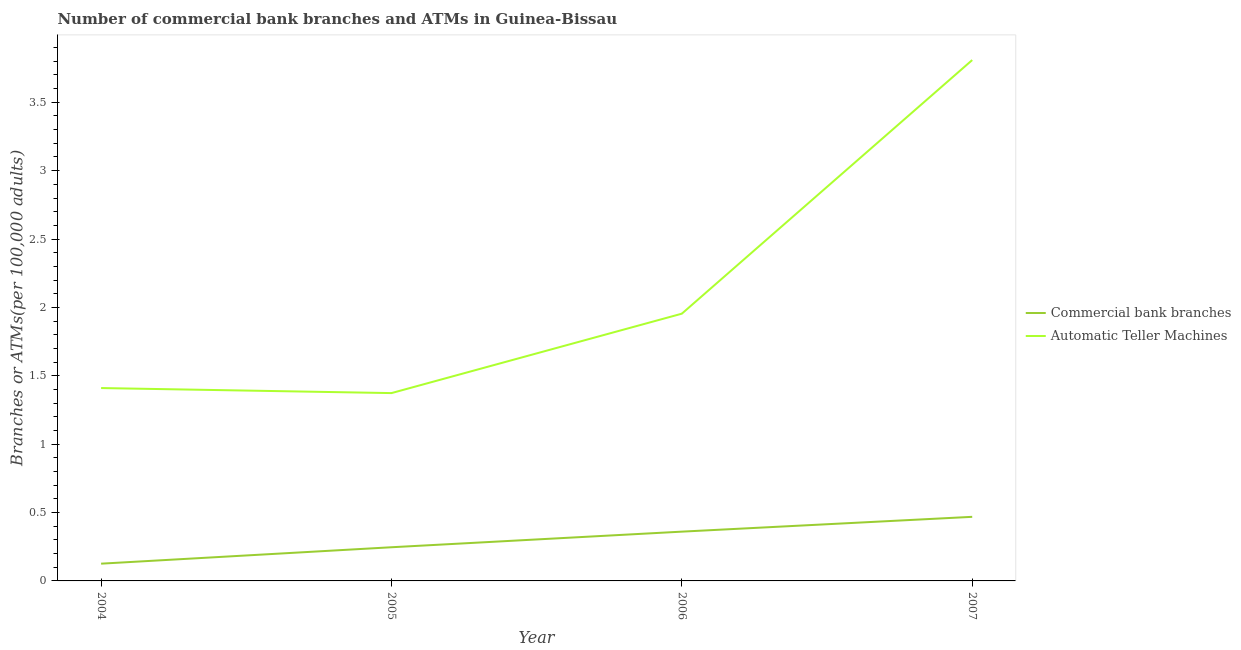How many different coloured lines are there?
Give a very brief answer. 2. Is the number of lines equal to the number of legend labels?
Offer a very short reply. Yes. What is the number of commercal bank branches in 2004?
Keep it short and to the point. 0.13. Across all years, what is the maximum number of atms?
Offer a very short reply. 3.81. Across all years, what is the minimum number of atms?
Offer a terse response. 1.37. In which year was the number of atms minimum?
Provide a succinct answer. 2005. What is the total number of commercal bank branches in the graph?
Your answer should be very brief. 1.2. What is the difference between the number of commercal bank branches in 2004 and that in 2005?
Provide a short and direct response. -0.12. What is the difference between the number of atms in 2005 and the number of commercal bank branches in 2006?
Ensure brevity in your answer.  1.01. What is the average number of atms per year?
Your answer should be compact. 2.14. In the year 2006, what is the difference between the number of atms and number of commercal bank branches?
Keep it short and to the point. 1.59. What is the ratio of the number of atms in 2005 to that in 2007?
Provide a short and direct response. 0.36. Is the number of atms in 2004 less than that in 2007?
Make the answer very short. Yes. Is the difference between the number of atms in 2004 and 2005 greater than the difference between the number of commercal bank branches in 2004 and 2005?
Keep it short and to the point. Yes. What is the difference between the highest and the second highest number of commercal bank branches?
Your answer should be very brief. 0.11. What is the difference between the highest and the lowest number of commercal bank branches?
Offer a very short reply. 0.34. In how many years, is the number of atms greater than the average number of atms taken over all years?
Provide a short and direct response. 1. Is the sum of the number of atms in 2006 and 2007 greater than the maximum number of commercal bank branches across all years?
Offer a very short reply. Yes. Does the number of atms monotonically increase over the years?
Make the answer very short. No. Is the number of atms strictly less than the number of commercal bank branches over the years?
Give a very brief answer. No. How many years are there in the graph?
Offer a terse response. 4. What is the difference between two consecutive major ticks on the Y-axis?
Offer a terse response. 0.5. Does the graph contain grids?
Offer a very short reply. No. How many legend labels are there?
Provide a short and direct response. 2. What is the title of the graph?
Your response must be concise. Number of commercial bank branches and ATMs in Guinea-Bissau. Does "Largest city" appear as one of the legend labels in the graph?
Provide a succinct answer. No. What is the label or title of the Y-axis?
Provide a short and direct response. Branches or ATMs(per 100,0 adults). What is the Branches or ATMs(per 100,000 adults) of Commercial bank branches in 2004?
Keep it short and to the point. 0.13. What is the Branches or ATMs(per 100,000 adults) in Automatic Teller Machines in 2004?
Ensure brevity in your answer.  1.41. What is the Branches or ATMs(per 100,000 adults) in Commercial bank branches in 2005?
Keep it short and to the point. 0.25. What is the Branches or ATMs(per 100,000 adults) of Automatic Teller Machines in 2005?
Offer a very short reply. 1.37. What is the Branches or ATMs(per 100,000 adults) of Commercial bank branches in 2006?
Your answer should be compact. 0.36. What is the Branches or ATMs(per 100,000 adults) of Automatic Teller Machines in 2006?
Your answer should be compact. 1.95. What is the Branches or ATMs(per 100,000 adults) of Commercial bank branches in 2007?
Make the answer very short. 0.47. What is the Branches or ATMs(per 100,000 adults) of Automatic Teller Machines in 2007?
Give a very brief answer. 3.81. Across all years, what is the maximum Branches or ATMs(per 100,000 adults) of Commercial bank branches?
Your answer should be very brief. 0.47. Across all years, what is the maximum Branches or ATMs(per 100,000 adults) of Automatic Teller Machines?
Give a very brief answer. 3.81. Across all years, what is the minimum Branches or ATMs(per 100,000 adults) in Commercial bank branches?
Your answer should be compact. 0.13. Across all years, what is the minimum Branches or ATMs(per 100,000 adults) of Automatic Teller Machines?
Ensure brevity in your answer.  1.37. What is the total Branches or ATMs(per 100,000 adults) in Commercial bank branches in the graph?
Give a very brief answer. 1.2. What is the total Branches or ATMs(per 100,000 adults) in Automatic Teller Machines in the graph?
Ensure brevity in your answer.  8.55. What is the difference between the Branches or ATMs(per 100,000 adults) of Commercial bank branches in 2004 and that in 2005?
Give a very brief answer. -0.12. What is the difference between the Branches or ATMs(per 100,000 adults) in Automatic Teller Machines in 2004 and that in 2005?
Make the answer very short. 0.04. What is the difference between the Branches or ATMs(per 100,000 adults) in Commercial bank branches in 2004 and that in 2006?
Give a very brief answer. -0.23. What is the difference between the Branches or ATMs(per 100,000 adults) in Automatic Teller Machines in 2004 and that in 2006?
Provide a short and direct response. -0.54. What is the difference between the Branches or ATMs(per 100,000 adults) of Commercial bank branches in 2004 and that in 2007?
Provide a short and direct response. -0.34. What is the difference between the Branches or ATMs(per 100,000 adults) of Automatic Teller Machines in 2004 and that in 2007?
Give a very brief answer. -2.4. What is the difference between the Branches or ATMs(per 100,000 adults) of Commercial bank branches in 2005 and that in 2006?
Keep it short and to the point. -0.11. What is the difference between the Branches or ATMs(per 100,000 adults) of Automatic Teller Machines in 2005 and that in 2006?
Your answer should be compact. -0.58. What is the difference between the Branches or ATMs(per 100,000 adults) of Commercial bank branches in 2005 and that in 2007?
Your answer should be compact. -0.22. What is the difference between the Branches or ATMs(per 100,000 adults) of Automatic Teller Machines in 2005 and that in 2007?
Offer a terse response. -2.44. What is the difference between the Branches or ATMs(per 100,000 adults) in Commercial bank branches in 2006 and that in 2007?
Your response must be concise. -0.11. What is the difference between the Branches or ATMs(per 100,000 adults) of Automatic Teller Machines in 2006 and that in 2007?
Your answer should be very brief. -1.85. What is the difference between the Branches or ATMs(per 100,000 adults) of Commercial bank branches in 2004 and the Branches or ATMs(per 100,000 adults) of Automatic Teller Machines in 2005?
Give a very brief answer. -1.25. What is the difference between the Branches or ATMs(per 100,000 adults) of Commercial bank branches in 2004 and the Branches or ATMs(per 100,000 adults) of Automatic Teller Machines in 2006?
Your answer should be compact. -1.83. What is the difference between the Branches or ATMs(per 100,000 adults) of Commercial bank branches in 2004 and the Branches or ATMs(per 100,000 adults) of Automatic Teller Machines in 2007?
Your answer should be compact. -3.68. What is the difference between the Branches or ATMs(per 100,000 adults) in Commercial bank branches in 2005 and the Branches or ATMs(per 100,000 adults) in Automatic Teller Machines in 2006?
Offer a terse response. -1.71. What is the difference between the Branches or ATMs(per 100,000 adults) in Commercial bank branches in 2005 and the Branches or ATMs(per 100,000 adults) in Automatic Teller Machines in 2007?
Provide a short and direct response. -3.56. What is the difference between the Branches or ATMs(per 100,000 adults) in Commercial bank branches in 2006 and the Branches or ATMs(per 100,000 adults) in Automatic Teller Machines in 2007?
Offer a terse response. -3.45. What is the average Branches or ATMs(per 100,000 adults) in Commercial bank branches per year?
Offer a very short reply. 0.3. What is the average Branches or ATMs(per 100,000 adults) in Automatic Teller Machines per year?
Give a very brief answer. 2.14. In the year 2004, what is the difference between the Branches or ATMs(per 100,000 adults) in Commercial bank branches and Branches or ATMs(per 100,000 adults) in Automatic Teller Machines?
Your response must be concise. -1.28. In the year 2005, what is the difference between the Branches or ATMs(per 100,000 adults) of Commercial bank branches and Branches or ATMs(per 100,000 adults) of Automatic Teller Machines?
Make the answer very short. -1.13. In the year 2006, what is the difference between the Branches or ATMs(per 100,000 adults) in Commercial bank branches and Branches or ATMs(per 100,000 adults) in Automatic Teller Machines?
Provide a succinct answer. -1.59. In the year 2007, what is the difference between the Branches or ATMs(per 100,000 adults) of Commercial bank branches and Branches or ATMs(per 100,000 adults) of Automatic Teller Machines?
Offer a terse response. -3.34. What is the ratio of the Branches or ATMs(per 100,000 adults) of Commercial bank branches in 2004 to that in 2005?
Provide a short and direct response. 0.51. What is the ratio of the Branches or ATMs(per 100,000 adults) in Automatic Teller Machines in 2004 to that in 2005?
Ensure brevity in your answer.  1.03. What is the ratio of the Branches or ATMs(per 100,000 adults) of Commercial bank branches in 2004 to that in 2006?
Offer a terse response. 0.35. What is the ratio of the Branches or ATMs(per 100,000 adults) of Automatic Teller Machines in 2004 to that in 2006?
Your response must be concise. 0.72. What is the ratio of the Branches or ATMs(per 100,000 adults) in Commercial bank branches in 2004 to that in 2007?
Your response must be concise. 0.27. What is the ratio of the Branches or ATMs(per 100,000 adults) of Automatic Teller Machines in 2004 to that in 2007?
Keep it short and to the point. 0.37. What is the ratio of the Branches or ATMs(per 100,000 adults) in Commercial bank branches in 2005 to that in 2006?
Provide a short and direct response. 0.68. What is the ratio of the Branches or ATMs(per 100,000 adults) in Automatic Teller Machines in 2005 to that in 2006?
Offer a very short reply. 0.7. What is the ratio of the Branches or ATMs(per 100,000 adults) of Commercial bank branches in 2005 to that in 2007?
Offer a very short reply. 0.53. What is the ratio of the Branches or ATMs(per 100,000 adults) in Automatic Teller Machines in 2005 to that in 2007?
Keep it short and to the point. 0.36. What is the ratio of the Branches or ATMs(per 100,000 adults) of Commercial bank branches in 2006 to that in 2007?
Your answer should be compact. 0.77. What is the ratio of the Branches or ATMs(per 100,000 adults) of Automatic Teller Machines in 2006 to that in 2007?
Give a very brief answer. 0.51. What is the difference between the highest and the second highest Branches or ATMs(per 100,000 adults) of Commercial bank branches?
Keep it short and to the point. 0.11. What is the difference between the highest and the second highest Branches or ATMs(per 100,000 adults) of Automatic Teller Machines?
Your response must be concise. 1.85. What is the difference between the highest and the lowest Branches or ATMs(per 100,000 adults) in Commercial bank branches?
Offer a terse response. 0.34. What is the difference between the highest and the lowest Branches or ATMs(per 100,000 adults) in Automatic Teller Machines?
Provide a short and direct response. 2.44. 